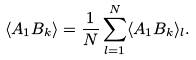<formula> <loc_0><loc_0><loc_500><loc_500>\langle A _ { 1 } B _ { k } \rangle = \frac { 1 } { N } \sum _ { l = 1 } ^ { N } \langle A _ { 1 } B _ { k } \rangle _ { l } .</formula> 